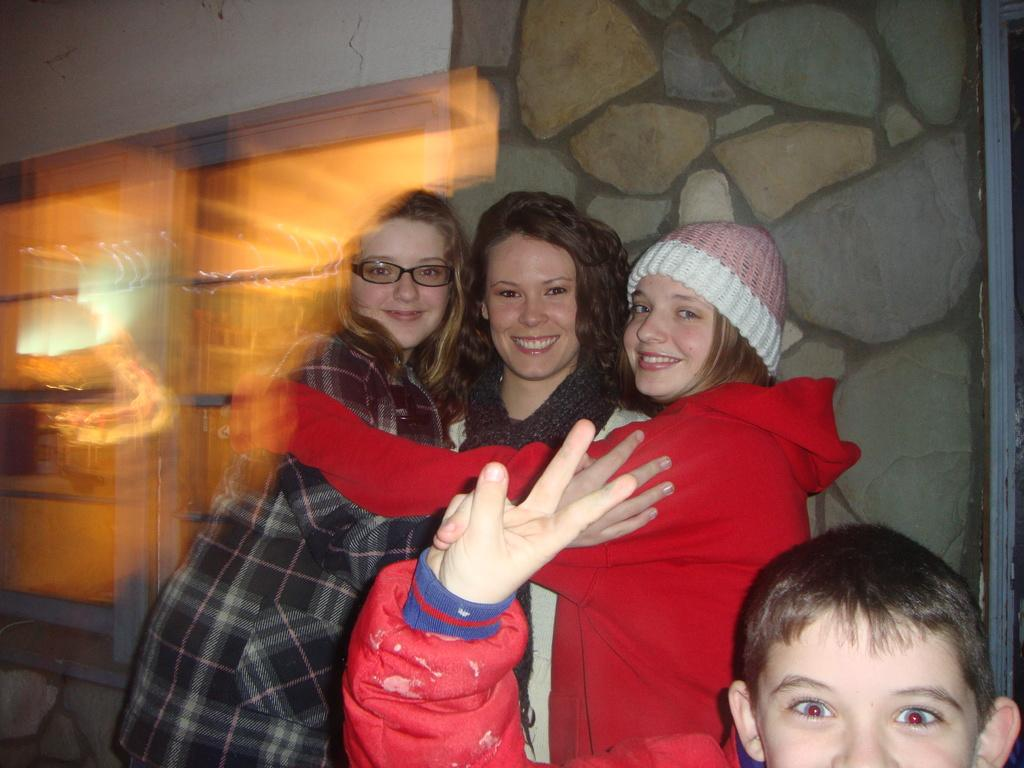What is happening in the center of the image? There are persons standing in the center of the image. Can you describe the position of the boy in the image? The boy is at the bottom of the image. What can be seen in the background of the image? There is a wall in the background of the image. What type of comb is the boy using in the image? There is no comb present in the image; the boy is simply standing at the bottom. How many knees can be seen in the image? The number of knees cannot be determined from the provided facts, as the focus is on the persons standing and the boy at the bottom. 